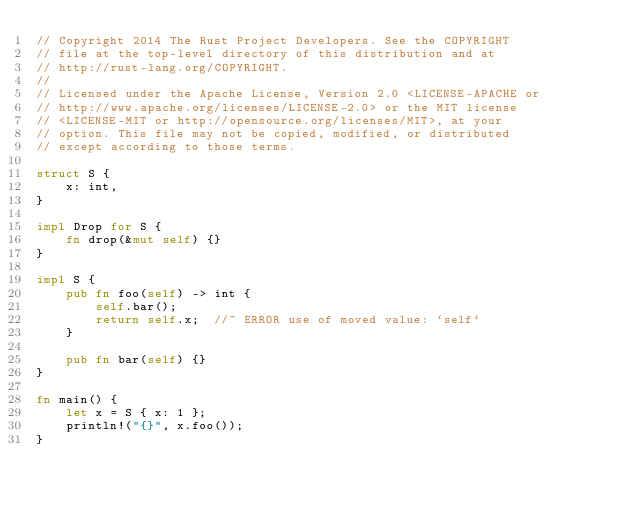<code> <loc_0><loc_0><loc_500><loc_500><_Rust_>// Copyright 2014 The Rust Project Developers. See the COPYRIGHT
// file at the top-level directory of this distribution and at
// http://rust-lang.org/COPYRIGHT.
//
// Licensed under the Apache License, Version 2.0 <LICENSE-APACHE or
// http://www.apache.org/licenses/LICENSE-2.0> or the MIT license
// <LICENSE-MIT or http://opensource.org/licenses/MIT>, at your
// option. This file may not be copied, modified, or distributed
// except according to those terms.

struct S {
    x: int,
}

impl Drop for S {
    fn drop(&mut self) {}
}

impl S {
    pub fn foo(self) -> int {
        self.bar();
        return self.x;  //~ ERROR use of moved value: `self`
    }

    pub fn bar(self) {}
}

fn main() {
    let x = S { x: 1 };
    println!("{}", x.foo());
}
</code> 